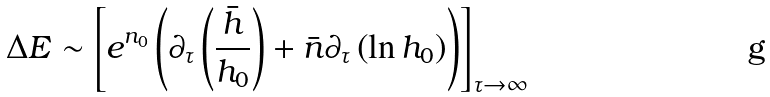<formula> <loc_0><loc_0><loc_500><loc_500>\Delta E \sim \left [ e ^ { n _ { 0 } } \left ( \partial _ { \tau } \left ( \frac { \bar { h } } { h _ { 0 } } \right ) + \bar { n } \partial _ { \tau } \left ( \ln h _ { 0 } \right ) \right ) \right ] _ { \tau \to \infty }</formula> 